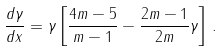Convert formula to latex. <formula><loc_0><loc_0><loc_500><loc_500>\frac { d \gamma } { d x } = \gamma \left [ \frac { 4 m - 5 } { m - 1 } - \frac { 2 m - 1 } { 2 m } \gamma \right ] \, .</formula> 